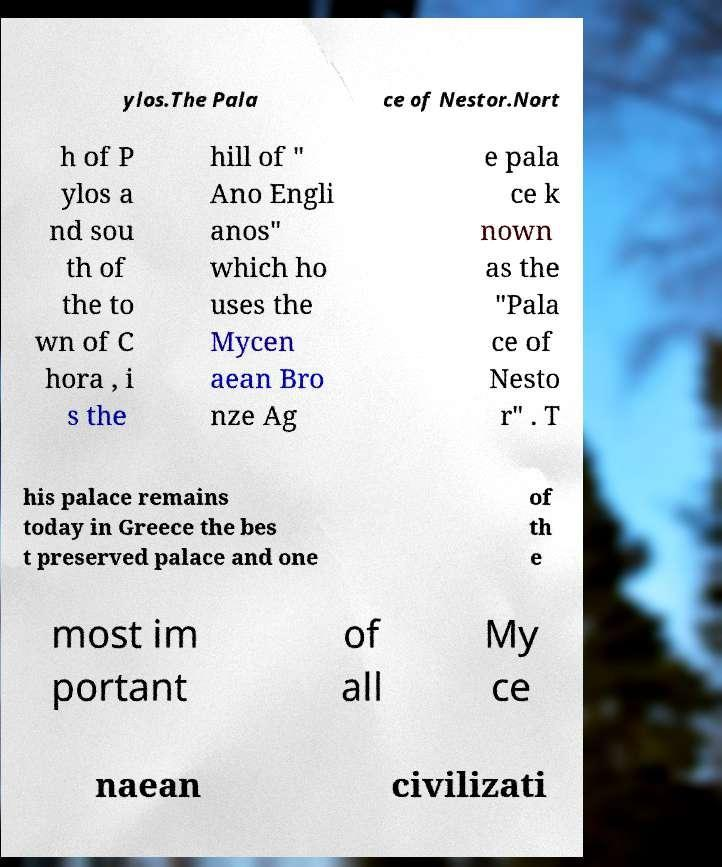Could you assist in decoding the text presented in this image and type it out clearly? ylos.The Pala ce of Nestor.Nort h of P ylos a nd sou th of the to wn of C hora , i s the hill of " Ano Engli anos" which ho uses the Mycen aean Bro nze Ag e pala ce k nown as the "Pala ce of Nesto r" . T his palace remains today in Greece the bes t preserved palace and one of th e most im portant of all My ce naean civilizati 